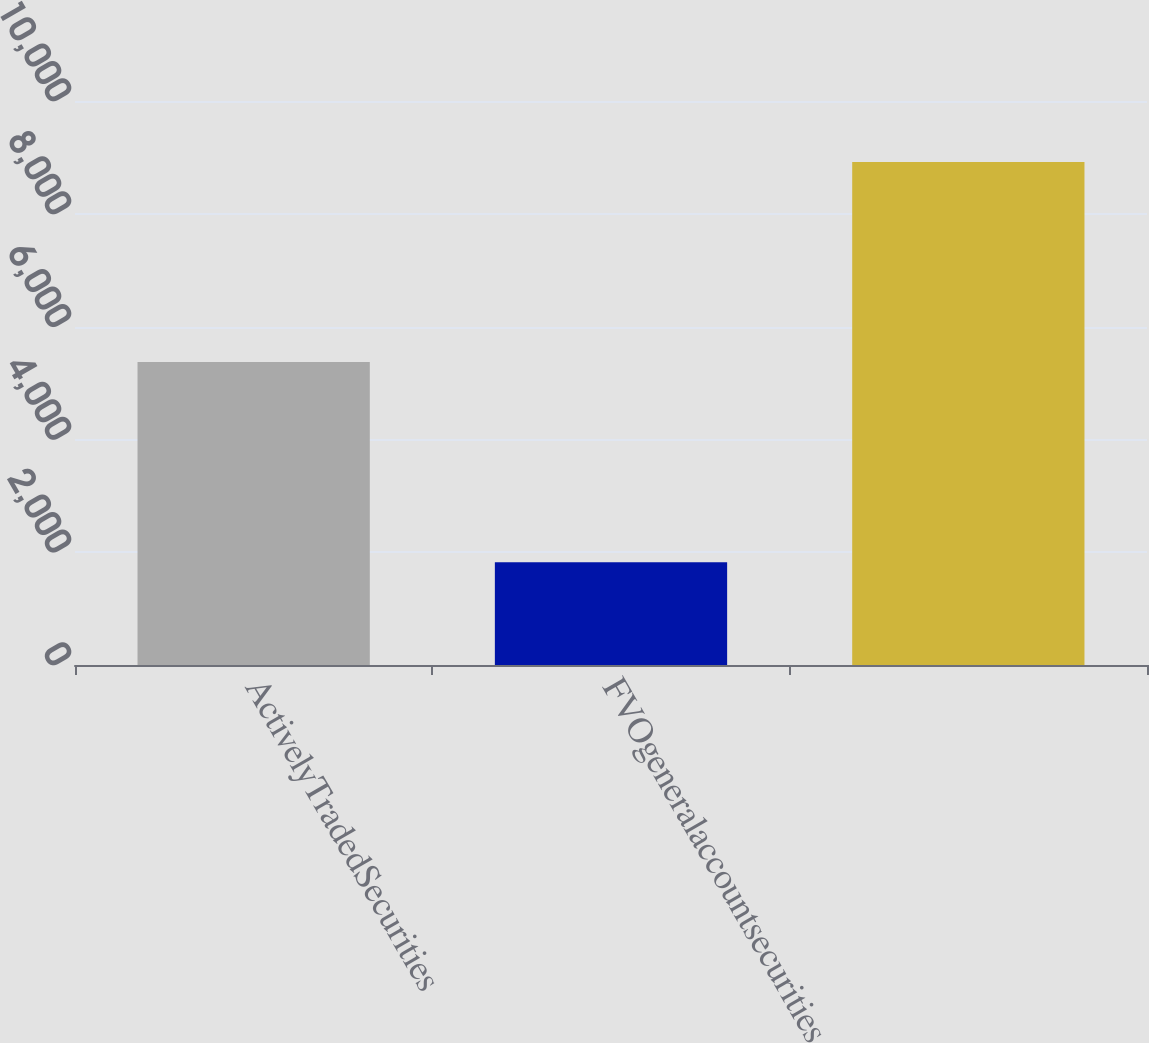<chart> <loc_0><loc_0><loc_500><loc_500><bar_chart><fcel>ActivelyTradedSecurities<fcel>FVOgeneralaccountsecurities<fcel>Unnamed: 2<nl><fcel>5370.4<fcel>1820.8<fcel>8920<nl></chart> 